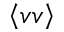Convert formula to latex. <formula><loc_0><loc_0><loc_500><loc_500>\left < v v \right ></formula> 